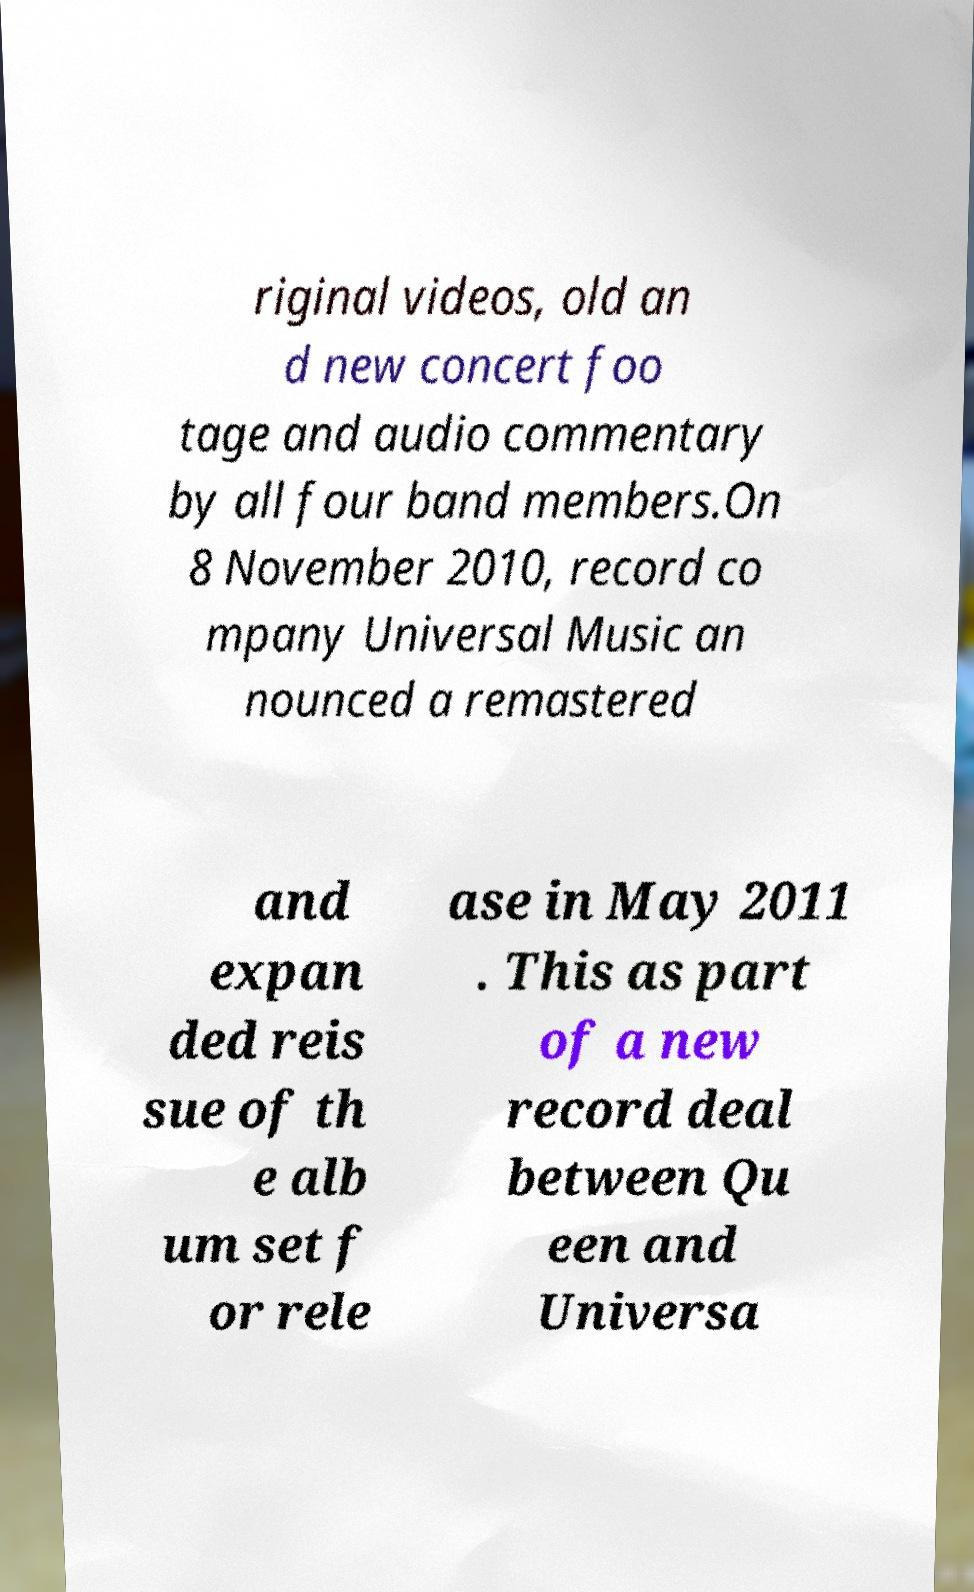Can you accurately transcribe the text from the provided image for me? riginal videos, old an d new concert foo tage and audio commentary by all four band members.On 8 November 2010, record co mpany Universal Music an nounced a remastered and expan ded reis sue of th e alb um set f or rele ase in May 2011 . This as part of a new record deal between Qu een and Universa 